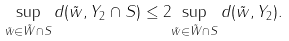Convert formula to latex. <formula><loc_0><loc_0><loc_500><loc_500>\underset { \tilde { w } \in \tilde { W } \cap S } { \sup } \, d ( \tilde { w } , Y _ { 2 } \cap S ) \leq 2 \underset { \tilde { w } \in \tilde { W } \cap S } { \sup } \, d ( \tilde { w } , Y _ { 2 } ) .</formula> 